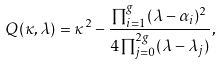Convert formula to latex. <formula><loc_0><loc_0><loc_500><loc_500>Q ( \kappa , \lambda ) = \kappa ^ { 2 } - \frac { \prod _ { i = 1 } ^ { g } ( \lambda - \alpha _ { i } ) ^ { 2 } } { 4 \prod _ { j = 0 } ^ { 2 g } ( \lambda - \lambda _ { j } ) } ,</formula> 